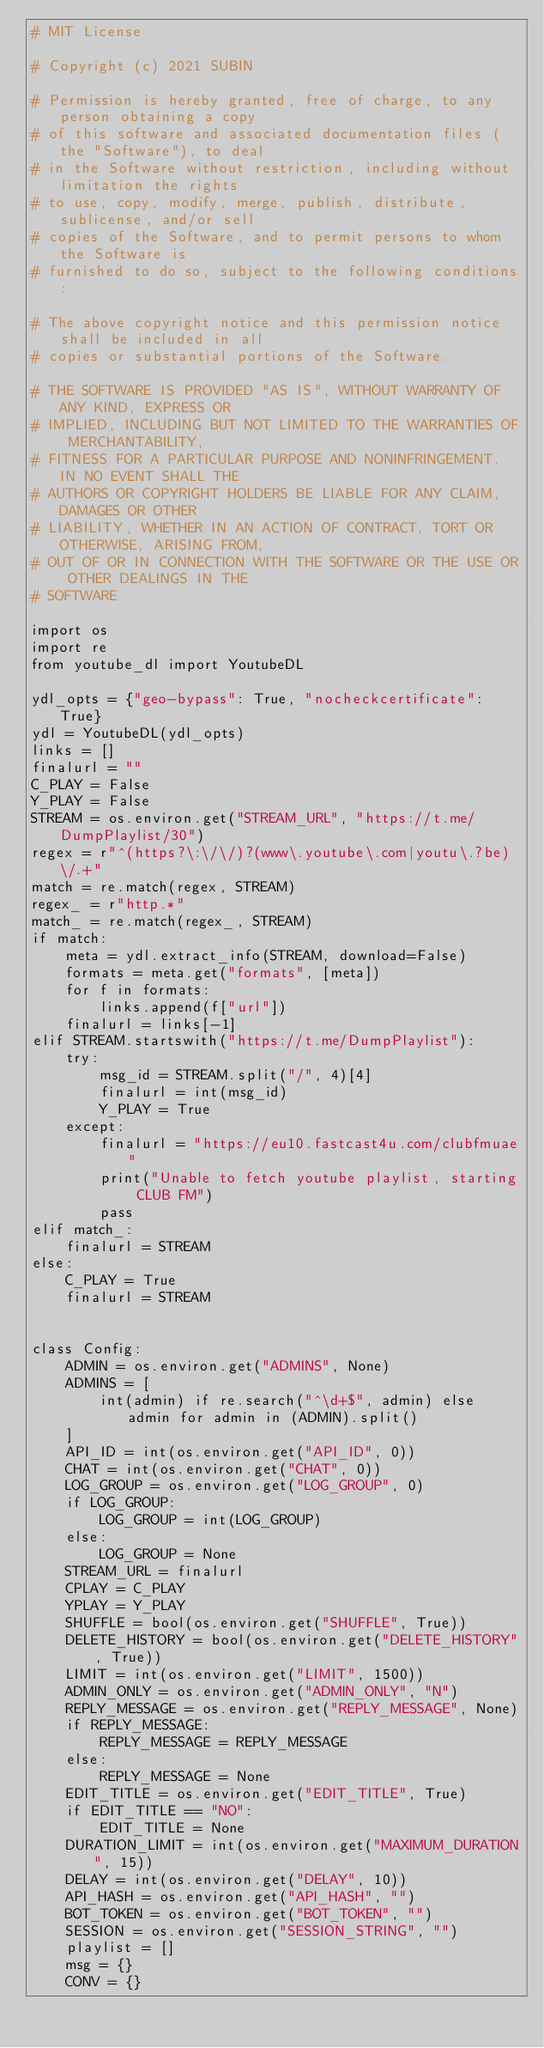Convert code to text. <code><loc_0><loc_0><loc_500><loc_500><_Python_># MIT License

# Copyright (c) 2021 SUBIN

# Permission is hereby granted, free of charge, to any person obtaining a copy
# of this software and associated documentation files (the "Software"), to deal
# in the Software without restriction, including without limitation the rights
# to use, copy, modify, merge, publish, distribute, sublicense, and/or sell
# copies of the Software, and to permit persons to whom the Software is
# furnished to do so, subject to the following conditions:

# The above copyright notice and this permission notice shall be included in all
# copies or substantial portions of the Software.

# THE SOFTWARE IS PROVIDED "AS IS", WITHOUT WARRANTY OF ANY KIND, EXPRESS OR
# IMPLIED, INCLUDING BUT NOT LIMITED TO THE WARRANTIES OF MERCHANTABILITY,
# FITNESS FOR A PARTICULAR PURPOSE AND NONINFRINGEMENT. IN NO EVENT SHALL THE
# AUTHORS OR COPYRIGHT HOLDERS BE LIABLE FOR ANY CLAIM, DAMAGES OR OTHER
# LIABILITY, WHETHER IN AN ACTION OF CONTRACT, TORT OR OTHERWISE, ARISING FROM,
# OUT OF OR IN CONNECTION WITH THE SOFTWARE OR THE USE OR OTHER DEALINGS IN THE
# SOFTWARE

import os
import re
from youtube_dl import YoutubeDL

ydl_opts = {"geo-bypass": True, "nocheckcertificate": True}
ydl = YoutubeDL(ydl_opts)
links = []
finalurl = ""
C_PLAY = False
Y_PLAY = False
STREAM = os.environ.get("STREAM_URL", "https://t.me/DumpPlaylist/30")
regex = r"^(https?\:\/\/)?(www\.youtube\.com|youtu\.?be)\/.+"
match = re.match(regex, STREAM)
regex_ = r"http.*"
match_ = re.match(regex_, STREAM)
if match:
    meta = ydl.extract_info(STREAM, download=False)
    formats = meta.get("formats", [meta])
    for f in formats:
        links.append(f["url"])
    finalurl = links[-1]
elif STREAM.startswith("https://t.me/DumpPlaylist"):
    try:
        msg_id = STREAM.split("/", 4)[4]
        finalurl = int(msg_id)
        Y_PLAY = True
    except:
        finalurl = "https://eu10.fastcast4u.com/clubfmuae"
        print("Unable to fetch youtube playlist, starting CLUB FM")
        pass
elif match_:
    finalurl = STREAM
else:
    C_PLAY = True
    finalurl = STREAM


class Config:
    ADMIN = os.environ.get("ADMINS", None)
    ADMINS = [
        int(admin) if re.search("^\d+$", admin) else admin for admin in (ADMIN).split()
    ]
    API_ID = int(os.environ.get("API_ID", 0))
    CHAT = int(os.environ.get("CHAT", 0))
    LOG_GROUP = os.environ.get("LOG_GROUP", 0)
    if LOG_GROUP:
        LOG_GROUP = int(LOG_GROUP)
    else:
        LOG_GROUP = None
    STREAM_URL = finalurl
    CPLAY = C_PLAY
    YPLAY = Y_PLAY
    SHUFFLE = bool(os.environ.get("SHUFFLE", True))
    DELETE_HISTORY = bool(os.environ.get("DELETE_HISTORY", True))
    LIMIT = int(os.environ.get("LIMIT", 1500))
    ADMIN_ONLY = os.environ.get("ADMIN_ONLY", "N")
    REPLY_MESSAGE = os.environ.get("REPLY_MESSAGE", None)
    if REPLY_MESSAGE:
        REPLY_MESSAGE = REPLY_MESSAGE
    else:
        REPLY_MESSAGE = None
    EDIT_TITLE = os.environ.get("EDIT_TITLE", True)
    if EDIT_TITLE == "NO":
        EDIT_TITLE = None
    DURATION_LIMIT = int(os.environ.get("MAXIMUM_DURATION", 15))
    DELAY = int(os.environ.get("DELAY", 10))
    API_HASH = os.environ.get("API_HASH", "")
    BOT_TOKEN = os.environ.get("BOT_TOKEN", "")
    SESSION = os.environ.get("SESSION_STRING", "")
    playlist = []
    msg = {}
    CONV = {}
</code> 